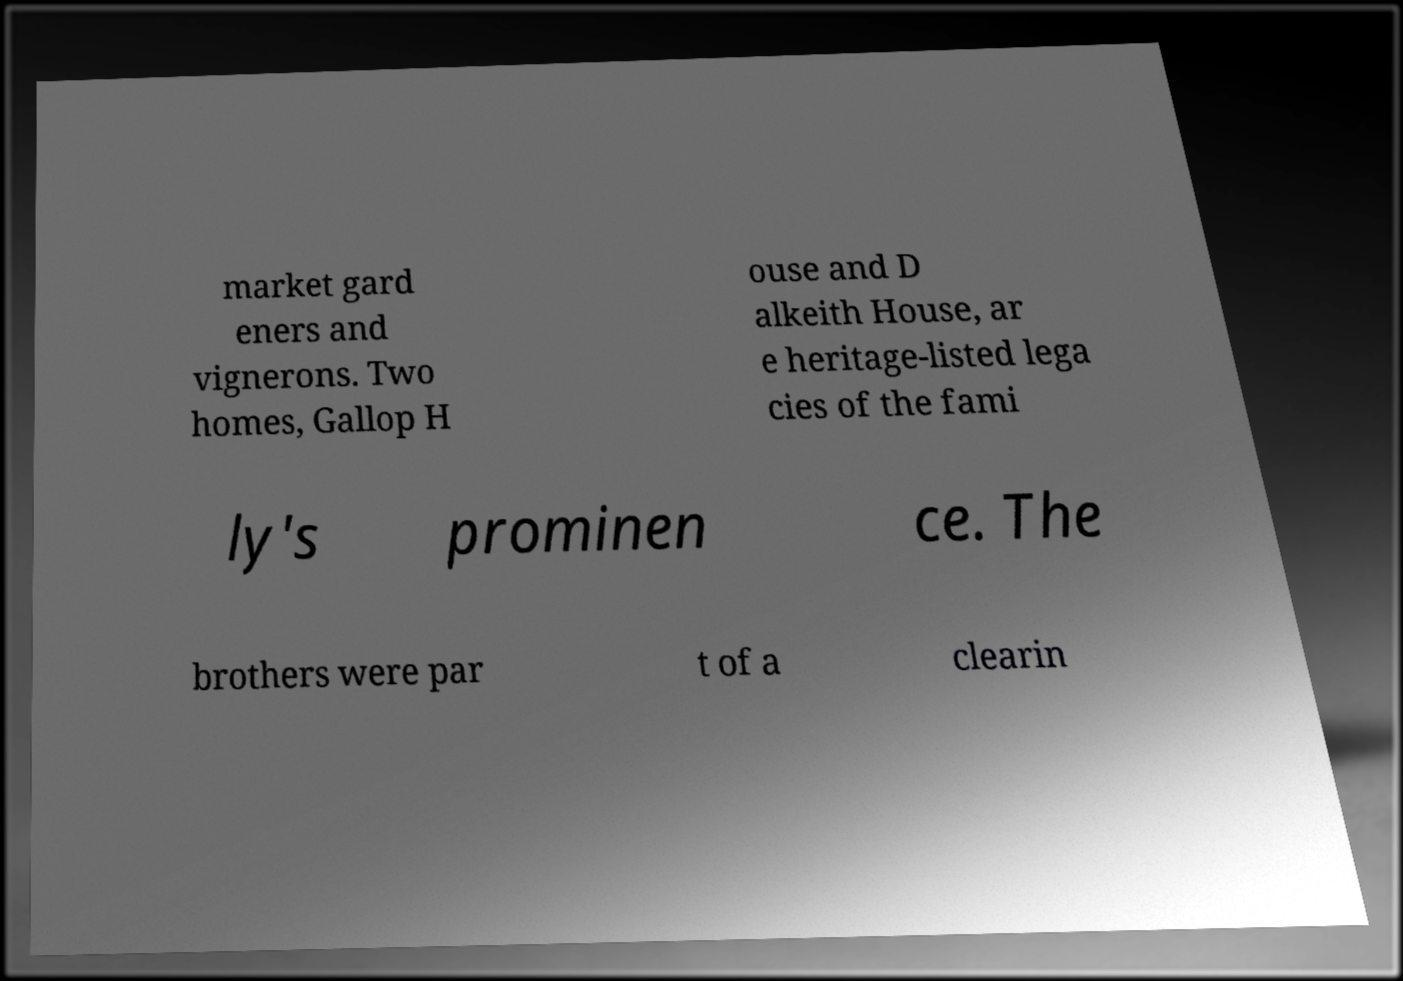Can you read and provide the text displayed in the image?This photo seems to have some interesting text. Can you extract and type it out for me? market gard eners and vignerons. Two homes, Gallop H ouse and D alkeith House, ar e heritage-listed lega cies of the fami ly's prominen ce. The brothers were par t of a clearin 